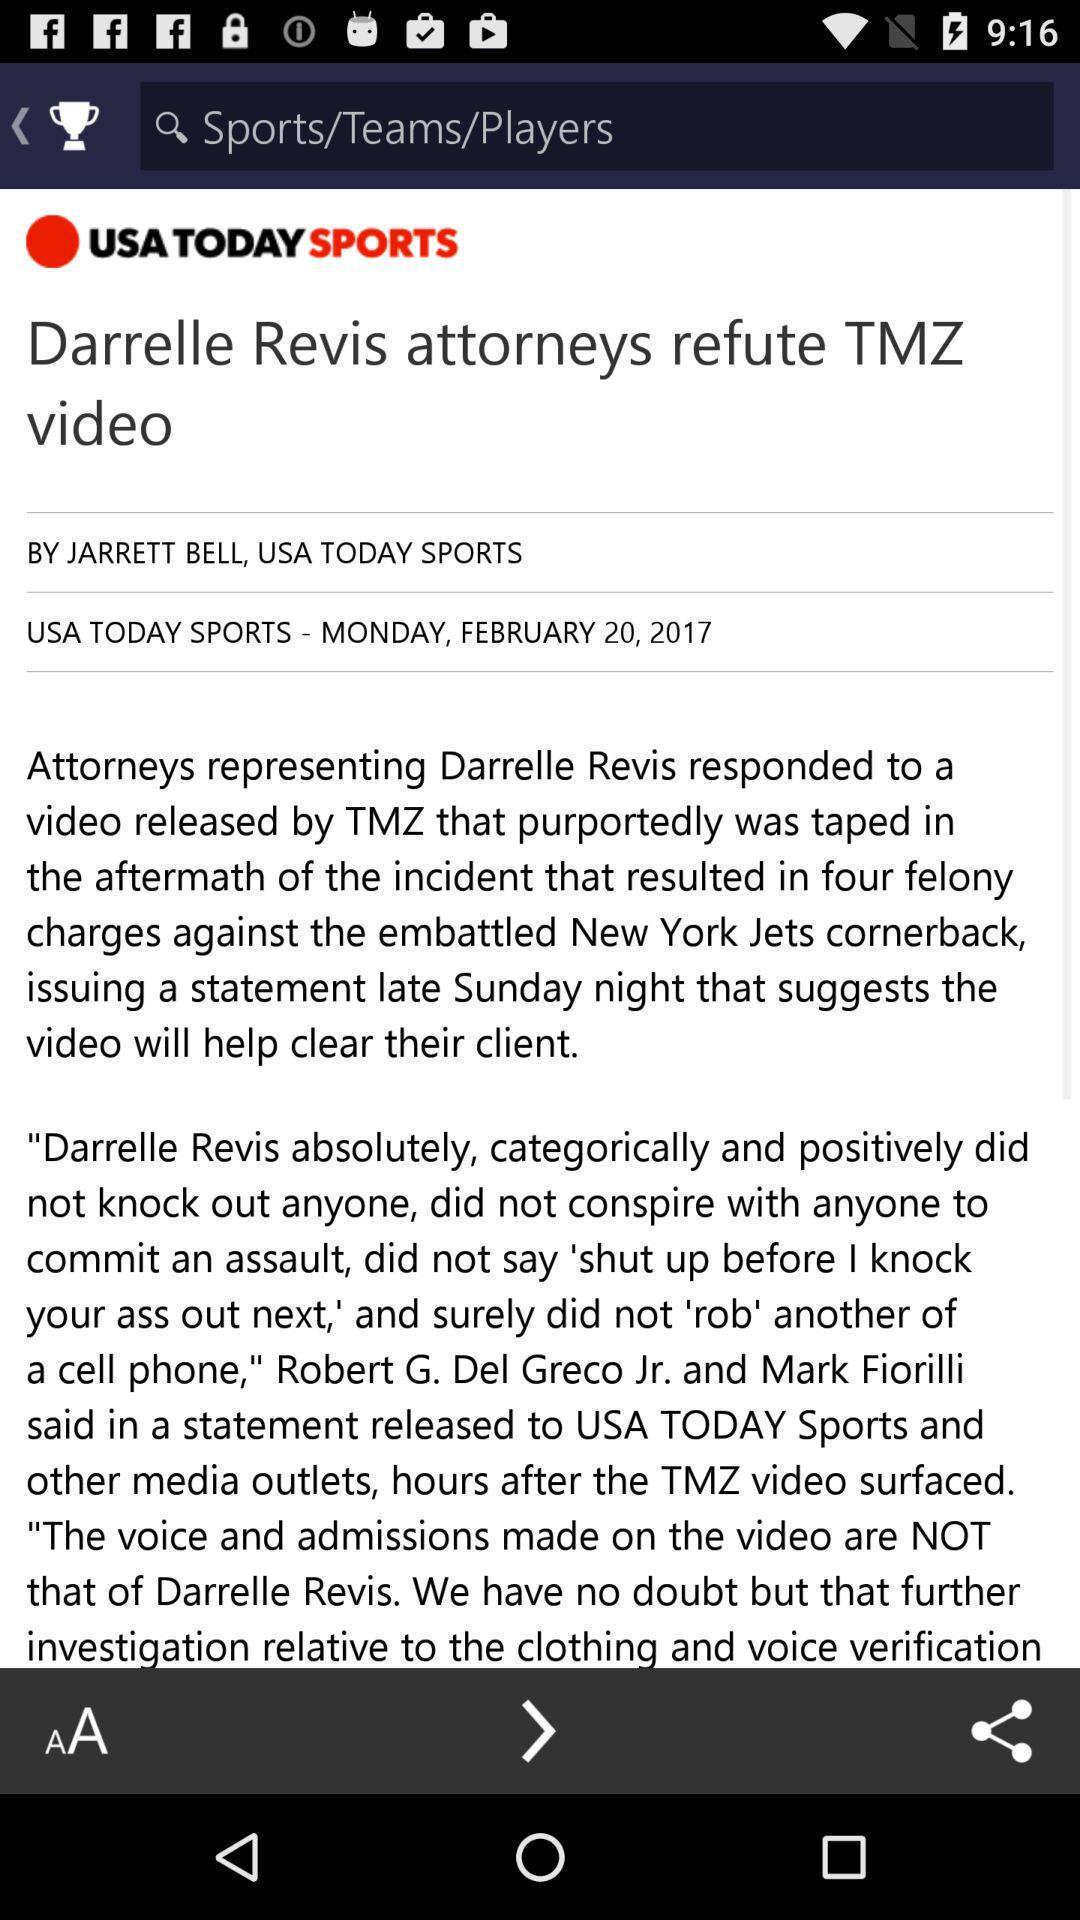What is the day? The day is "MONDAY". 